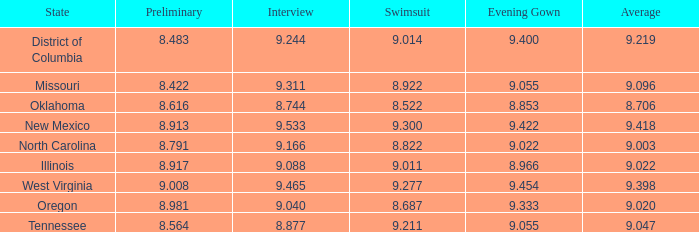Name the preliminary for north carolina 8.791. 